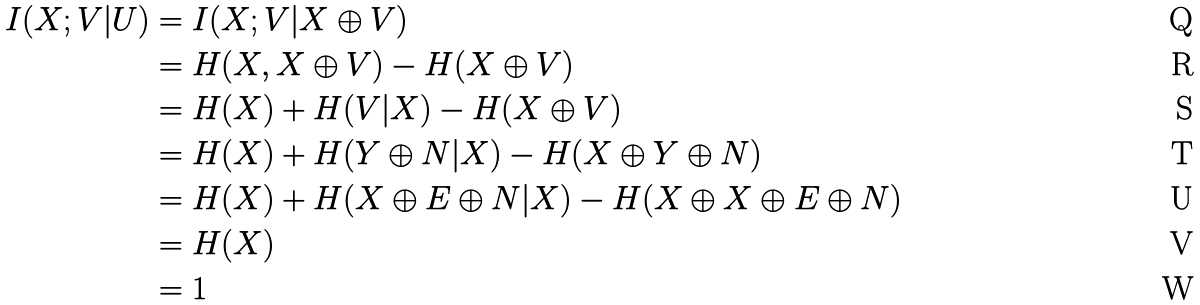<formula> <loc_0><loc_0><loc_500><loc_500>I ( X ; V | U ) & = I ( X ; V | X \oplus V ) \\ & = H ( X , X \oplus V ) - H ( X \oplus V ) \\ & = H ( X ) + H ( V | X ) - H ( X \oplus V ) \\ & = H ( X ) + H ( Y \oplus N | X ) - H ( X \oplus Y \oplus N ) \\ & = H ( X ) + H ( X \oplus E \oplus N | X ) - H ( X \oplus X \oplus E \oplus N ) \\ & = H ( X ) \\ & = 1</formula> 